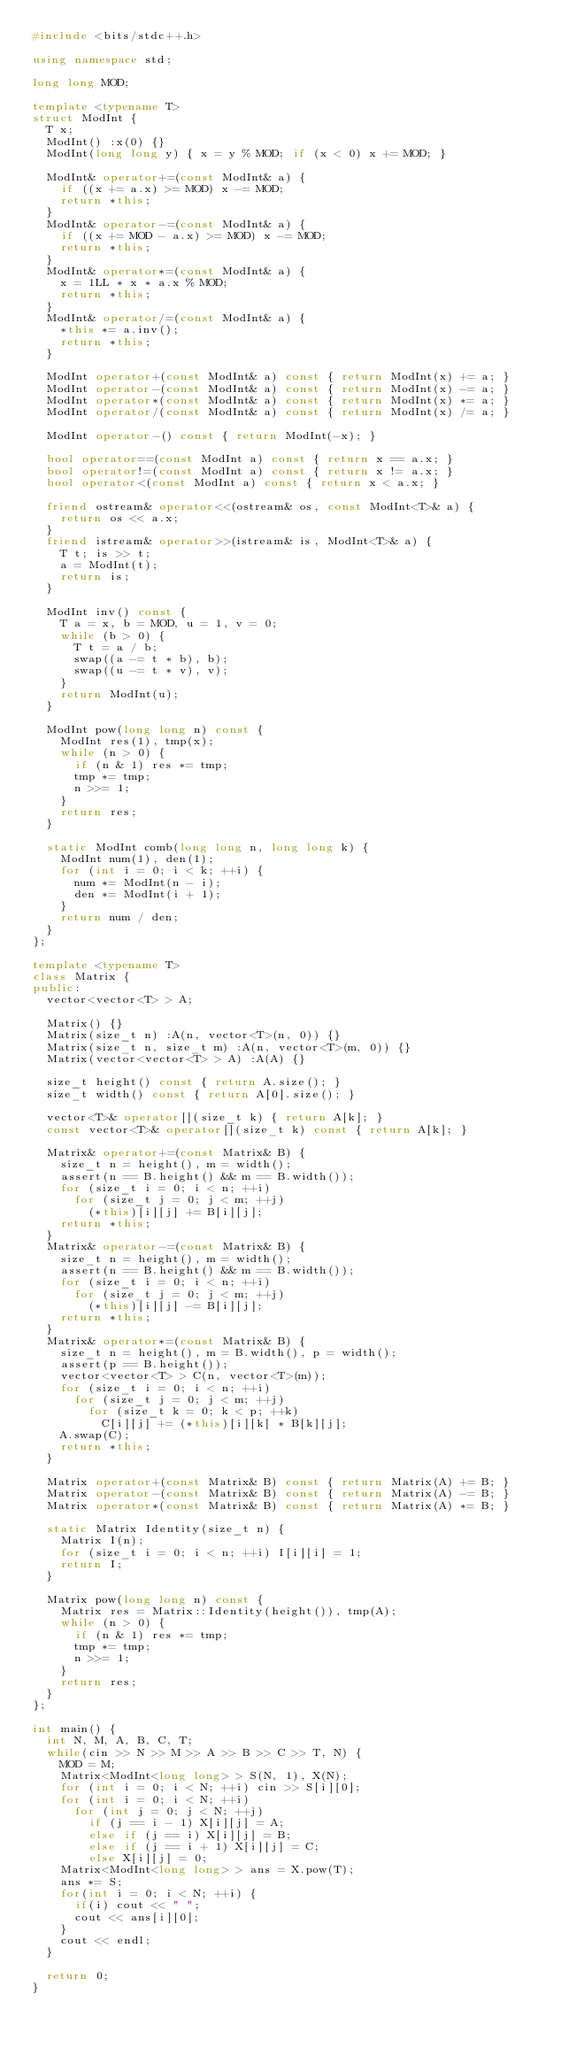Convert code to text. <code><loc_0><loc_0><loc_500><loc_500><_C++_>#include <bits/stdc++.h>

using namespace std;

long long MOD;

template <typename T>
struct ModInt {
  T x;
  ModInt() :x(0) {}
  ModInt(long long y) { x = y % MOD; if (x < 0) x += MOD; }

  ModInt& operator+=(const ModInt& a) {
    if ((x += a.x) >= MOD) x -= MOD;
    return *this;
  }
  ModInt& operator-=(const ModInt& a) {
    if ((x += MOD - a.x) >= MOD) x -= MOD;
    return *this;
  }
  ModInt& operator*=(const ModInt& a) {
    x = 1LL * x * a.x % MOD;
    return *this;
  }
  ModInt& operator/=(const ModInt& a) {
    *this *= a.inv();
    return *this;
  }

  ModInt operator+(const ModInt& a) const { return ModInt(x) += a; }
  ModInt operator-(const ModInt& a) const { return ModInt(x) -= a; }
  ModInt operator*(const ModInt& a) const { return ModInt(x) *= a; }
  ModInt operator/(const ModInt& a) const { return ModInt(x) /= a; }

  ModInt operator-() const { return ModInt(-x); }

  bool operator==(const ModInt a) const { return x == a.x; }
  bool operator!=(const ModInt a) const { return x != a.x; }
  bool operator<(const ModInt a) const { return x < a.x; }

  friend ostream& operator<<(ostream& os, const ModInt<T>& a) {
    return os << a.x;
  }
  friend istream& operator>>(istream& is, ModInt<T>& a) {
    T t; is >> t;
    a = ModInt(t);
    return is;
  }

  ModInt inv() const {
    T a = x, b = MOD, u = 1, v = 0;
    while (b > 0) {
      T t = a / b;
      swap((a -= t * b), b);
      swap((u -= t * v), v);
    }
    return ModInt(u);
  }

  ModInt pow(long long n) const {
    ModInt res(1), tmp(x);
    while (n > 0) {
      if (n & 1) res *= tmp;
      tmp *= tmp;
      n >>= 1;
    }
    return res;
  }

  static ModInt comb(long long n, long long k) {
    ModInt num(1), den(1);
    for (int i = 0; i < k; ++i) {
      num *= ModInt(n - i);
      den *= ModInt(i + 1);
    }
    return num / den;
  }
};

template <typename T>
class Matrix {
public:
  vector<vector<T> > A;

  Matrix() {}
  Matrix(size_t n) :A(n, vector<T>(n, 0)) {}
  Matrix(size_t n, size_t m) :A(n, vector<T>(m, 0)) {}
  Matrix(vector<vector<T> > A) :A(A) {}

  size_t height() const { return A.size(); }
  size_t width() const { return A[0].size(); }

  vector<T>& operator[](size_t k) { return A[k]; }
  const vector<T>& operator[](size_t k) const { return A[k]; }

  Matrix& operator+=(const Matrix& B) {
    size_t n = height(), m = width();
    assert(n == B.height() && m == B.width());
    for (size_t i = 0; i < n; ++i)
      for (size_t j = 0; j < m; ++j)
        (*this)[i][j] += B[i][j];
    return *this;
  }
  Matrix& operator-=(const Matrix& B) {
    size_t n = height(), m = width();
    assert(n == B.height() && m == B.width());
    for (size_t i = 0; i < n; ++i)
      for (size_t j = 0; j < m; ++j)
        (*this)[i][j] -= B[i][j];
    return *this;
  }
  Matrix& operator*=(const Matrix& B) {
    size_t n = height(), m = B.width(), p = width();
    assert(p == B.height());
    vector<vector<T> > C(n, vector<T>(m));
    for (size_t i = 0; i < n; ++i)
      for (size_t j = 0; j < m; ++j)
        for (size_t k = 0; k < p; ++k)
          C[i][j] += (*this)[i][k] * B[k][j];
    A.swap(C);
    return *this;
  }

  Matrix operator+(const Matrix& B) const { return Matrix(A) += B; }
  Matrix operator-(const Matrix& B) const { return Matrix(A) -= B; }
  Matrix operator*(const Matrix& B) const { return Matrix(A) *= B; }

  static Matrix Identity(size_t n) {
    Matrix I(n);
    for (size_t i = 0; i < n; ++i) I[i][i] = 1;
    return I;
  }

  Matrix pow(long long n) const {
    Matrix res = Matrix::Identity(height()), tmp(A);
    while (n > 0) {
      if (n & 1) res *= tmp;
      tmp *= tmp;
      n >>= 1;
    }
    return res;
  }
};

int main() {
  int N, M, A, B, C, T;
  while(cin >> N >> M >> A >> B >> C >> T, N) {
    MOD = M;
    Matrix<ModInt<long long> > S(N, 1), X(N);
    for (int i = 0; i < N; ++i) cin >> S[i][0];
    for (int i = 0; i < N; ++i)
      for (int j = 0; j < N; ++j)
        if (j == i - 1) X[i][j] = A;
        else if (j == i) X[i][j] = B;
        else if (j == i + 1) X[i][j] = C;
        else X[i][j] = 0;
    Matrix<ModInt<long long> > ans = X.pow(T);
    ans *= S;
    for(int i = 0; i < N; ++i) {
      if(i) cout << " ";
      cout << ans[i][0];
    }
    cout << endl;
  }
  
  return 0;
}
</code> 